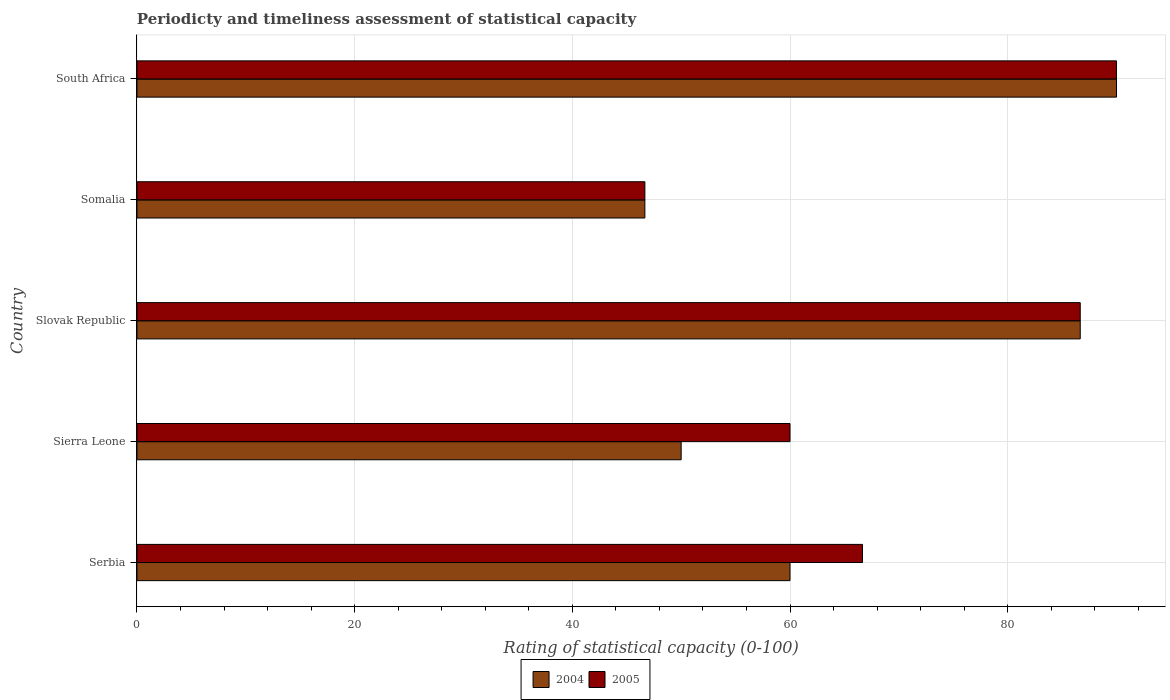How many groups of bars are there?
Your answer should be very brief. 5. How many bars are there on the 1st tick from the bottom?
Ensure brevity in your answer.  2. What is the label of the 1st group of bars from the top?
Keep it short and to the point. South Africa. In how many cases, is the number of bars for a given country not equal to the number of legend labels?
Your answer should be very brief. 0. Across all countries, what is the minimum rating of statistical capacity in 2004?
Give a very brief answer. 46.67. In which country was the rating of statistical capacity in 2004 maximum?
Provide a succinct answer. South Africa. In which country was the rating of statistical capacity in 2005 minimum?
Provide a succinct answer. Somalia. What is the total rating of statistical capacity in 2004 in the graph?
Keep it short and to the point. 333.33. What is the difference between the rating of statistical capacity in 2004 in Serbia and that in Slovak Republic?
Offer a terse response. -26.67. What is the average rating of statistical capacity in 2005 per country?
Provide a short and direct response. 70. In how many countries, is the rating of statistical capacity in 2005 greater than 28 ?
Your response must be concise. 5. What is the ratio of the rating of statistical capacity in 2004 in Sierra Leone to that in Slovak Republic?
Your answer should be very brief. 0.58. Is the difference between the rating of statistical capacity in 2005 in Sierra Leone and South Africa greater than the difference between the rating of statistical capacity in 2004 in Sierra Leone and South Africa?
Make the answer very short. Yes. What is the difference between the highest and the second highest rating of statistical capacity in 2004?
Provide a succinct answer. 3.33. What is the difference between the highest and the lowest rating of statistical capacity in 2004?
Ensure brevity in your answer.  43.33. In how many countries, is the rating of statistical capacity in 2004 greater than the average rating of statistical capacity in 2004 taken over all countries?
Provide a succinct answer. 2. How many bars are there?
Give a very brief answer. 10. Are all the bars in the graph horizontal?
Make the answer very short. Yes. How many countries are there in the graph?
Your response must be concise. 5. Are the values on the major ticks of X-axis written in scientific E-notation?
Offer a very short reply. No. Does the graph contain grids?
Ensure brevity in your answer.  Yes. How many legend labels are there?
Ensure brevity in your answer.  2. What is the title of the graph?
Your response must be concise. Periodicty and timeliness assessment of statistical capacity. Does "1971" appear as one of the legend labels in the graph?
Ensure brevity in your answer.  No. What is the label or title of the X-axis?
Make the answer very short. Rating of statistical capacity (0-100). What is the label or title of the Y-axis?
Provide a succinct answer. Country. What is the Rating of statistical capacity (0-100) of 2005 in Serbia?
Make the answer very short. 66.66. What is the Rating of statistical capacity (0-100) in 2005 in Sierra Leone?
Ensure brevity in your answer.  60. What is the Rating of statistical capacity (0-100) in 2004 in Slovak Republic?
Keep it short and to the point. 86.67. What is the Rating of statistical capacity (0-100) in 2005 in Slovak Republic?
Ensure brevity in your answer.  86.67. What is the Rating of statistical capacity (0-100) of 2004 in Somalia?
Offer a terse response. 46.67. What is the Rating of statistical capacity (0-100) of 2005 in Somalia?
Ensure brevity in your answer.  46.67. What is the Rating of statistical capacity (0-100) of 2005 in South Africa?
Your response must be concise. 90. Across all countries, what is the maximum Rating of statistical capacity (0-100) of 2004?
Provide a short and direct response. 90. Across all countries, what is the maximum Rating of statistical capacity (0-100) of 2005?
Provide a short and direct response. 90. Across all countries, what is the minimum Rating of statistical capacity (0-100) of 2004?
Provide a succinct answer. 46.67. Across all countries, what is the minimum Rating of statistical capacity (0-100) in 2005?
Give a very brief answer. 46.67. What is the total Rating of statistical capacity (0-100) in 2004 in the graph?
Your answer should be very brief. 333.33. What is the total Rating of statistical capacity (0-100) in 2005 in the graph?
Offer a terse response. 349.99. What is the difference between the Rating of statistical capacity (0-100) in 2004 in Serbia and that in Sierra Leone?
Offer a terse response. 10. What is the difference between the Rating of statistical capacity (0-100) in 2005 in Serbia and that in Sierra Leone?
Offer a terse response. 6.66. What is the difference between the Rating of statistical capacity (0-100) in 2004 in Serbia and that in Slovak Republic?
Ensure brevity in your answer.  -26.67. What is the difference between the Rating of statistical capacity (0-100) in 2005 in Serbia and that in Slovak Republic?
Offer a terse response. -20.01. What is the difference between the Rating of statistical capacity (0-100) of 2004 in Serbia and that in Somalia?
Keep it short and to the point. 13.33. What is the difference between the Rating of statistical capacity (0-100) of 2005 in Serbia and that in Somalia?
Your response must be concise. 19.99. What is the difference between the Rating of statistical capacity (0-100) in 2004 in Serbia and that in South Africa?
Offer a very short reply. -30. What is the difference between the Rating of statistical capacity (0-100) in 2005 in Serbia and that in South Africa?
Keep it short and to the point. -23.34. What is the difference between the Rating of statistical capacity (0-100) in 2004 in Sierra Leone and that in Slovak Republic?
Keep it short and to the point. -36.67. What is the difference between the Rating of statistical capacity (0-100) of 2005 in Sierra Leone and that in Slovak Republic?
Provide a succinct answer. -26.67. What is the difference between the Rating of statistical capacity (0-100) of 2005 in Sierra Leone and that in Somalia?
Offer a terse response. 13.33. What is the difference between the Rating of statistical capacity (0-100) of 2005 in Sierra Leone and that in South Africa?
Offer a very short reply. -30. What is the difference between the Rating of statistical capacity (0-100) of 2004 in Slovak Republic and that in Somalia?
Ensure brevity in your answer.  40. What is the difference between the Rating of statistical capacity (0-100) in 2004 in Somalia and that in South Africa?
Provide a succinct answer. -43.33. What is the difference between the Rating of statistical capacity (0-100) in 2005 in Somalia and that in South Africa?
Your answer should be compact. -43.33. What is the difference between the Rating of statistical capacity (0-100) in 2004 in Serbia and the Rating of statistical capacity (0-100) in 2005 in Slovak Republic?
Give a very brief answer. -26.67. What is the difference between the Rating of statistical capacity (0-100) of 2004 in Serbia and the Rating of statistical capacity (0-100) of 2005 in Somalia?
Ensure brevity in your answer.  13.33. What is the difference between the Rating of statistical capacity (0-100) in 2004 in Serbia and the Rating of statistical capacity (0-100) in 2005 in South Africa?
Give a very brief answer. -30. What is the difference between the Rating of statistical capacity (0-100) in 2004 in Sierra Leone and the Rating of statistical capacity (0-100) in 2005 in Slovak Republic?
Keep it short and to the point. -36.67. What is the difference between the Rating of statistical capacity (0-100) in 2004 in Sierra Leone and the Rating of statistical capacity (0-100) in 2005 in Somalia?
Provide a short and direct response. 3.33. What is the difference between the Rating of statistical capacity (0-100) of 2004 in Slovak Republic and the Rating of statistical capacity (0-100) of 2005 in Somalia?
Your answer should be very brief. 40. What is the difference between the Rating of statistical capacity (0-100) in 2004 in Somalia and the Rating of statistical capacity (0-100) in 2005 in South Africa?
Keep it short and to the point. -43.33. What is the average Rating of statistical capacity (0-100) in 2004 per country?
Make the answer very short. 66.67. What is the average Rating of statistical capacity (0-100) in 2005 per country?
Your answer should be very brief. 70. What is the difference between the Rating of statistical capacity (0-100) in 2004 and Rating of statistical capacity (0-100) in 2005 in Serbia?
Your answer should be compact. -6.66. What is the difference between the Rating of statistical capacity (0-100) in 2004 and Rating of statistical capacity (0-100) in 2005 in Sierra Leone?
Your answer should be very brief. -10. What is the difference between the Rating of statistical capacity (0-100) of 2004 and Rating of statistical capacity (0-100) of 2005 in Slovak Republic?
Provide a succinct answer. 0. What is the difference between the Rating of statistical capacity (0-100) in 2004 and Rating of statistical capacity (0-100) in 2005 in South Africa?
Provide a short and direct response. 0. What is the ratio of the Rating of statistical capacity (0-100) of 2005 in Serbia to that in Sierra Leone?
Keep it short and to the point. 1.11. What is the ratio of the Rating of statistical capacity (0-100) in 2004 in Serbia to that in Slovak Republic?
Your response must be concise. 0.69. What is the ratio of the Rating of statistical capacity (0-100) of 2005 in Serbia to that in Slovak Republic?
Make the answer very short. 0.77. What is the ratio of the Rating of statistical capacity (0-100) of 2005 in Serbia to that in Somalia?
Offer a very short reply. 1.43. What is the ratio of the Rating of statistical capacity (0-100) of 2005 in Serbia to that in South Africa?
Offer a very short reply. 0.74. What is the ratio of the Rating of statistical capacity (0-100) in 2004 in Sierra Leone to that in Slovak Republic?
Offer a very short reply. 0.58. What is the ratio of the Rating of statistical capacity (0-100) of 2005 in Sierra Leone to that in Slovak Republic?
Your answer should be compact. 0.69. What is the ratio of the Rating of statistical capacity (0-100) in 2004 in Sierra Leone to that in Somalia?
Your answer should be very brief. 1.07. What is the ratio of the Rating of statistical capacity (0-100) of 2004 in Sierra Leone to that in South Africa?
Give a very brief answer. 0.56. What is the ratio of the Rating of statistical capacity (0-100) in 2005 in Sierra Leone to that in South Africa?
Give a very brief answer. 0.67. What is the ratio of the Rating of statistical capacity (0-100) of 2004 in Slovak Republic to that in Somalia?
Provide a succinct answer. 1.86. What is the ratio of the Rating of statistical capacity (0-100) in 2005 in Slovak Republic to that in Somalia?
Give a very brief answer. 1.86. What is the ratio of the Rating of statistical capacity (0-100) of 2004 in Slovak Republic to that in South Africa?
Make the answer very short. 0.96. What is the ratio of the Rating of statistical capacity (0-100) in 2004 in Somalia to that in South Africa?
Provide a succinct answer. 0.52. What is the ratio of the Rating of statistical capacity (0-100) in 2005 in Somalia to that in South Africa?
Offer a very short reply. 0.52. What is the difference between the highest and the second highest Rating of statistical capacity (0-100) of 2005?
Your answer should be very brief. 3.33. What is the difference between the highest and the lowest Rating of statistical capacity (0-100) of 2004?
Make the answer very short. 43.33. What is the difference between the highest and the lowest Rating of statistical capacity (0-100) of 2005?
Offer a terse response. 43.33. 